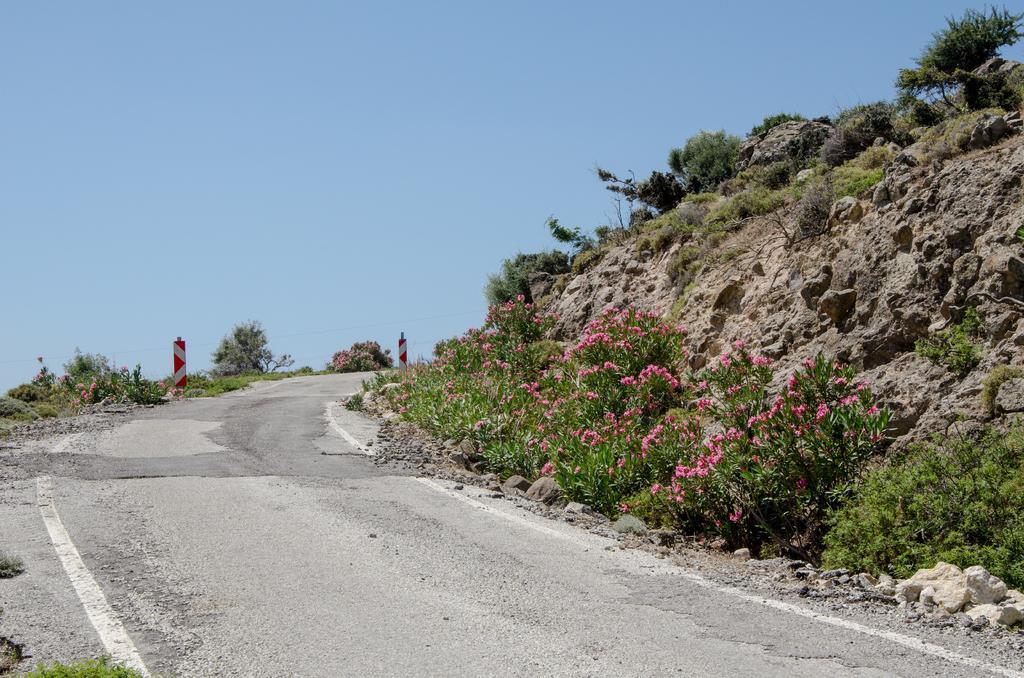Describe this image in one or two sentences. In this image there is a road, beside the road there are sign boards, flowers on plants and rocks. 